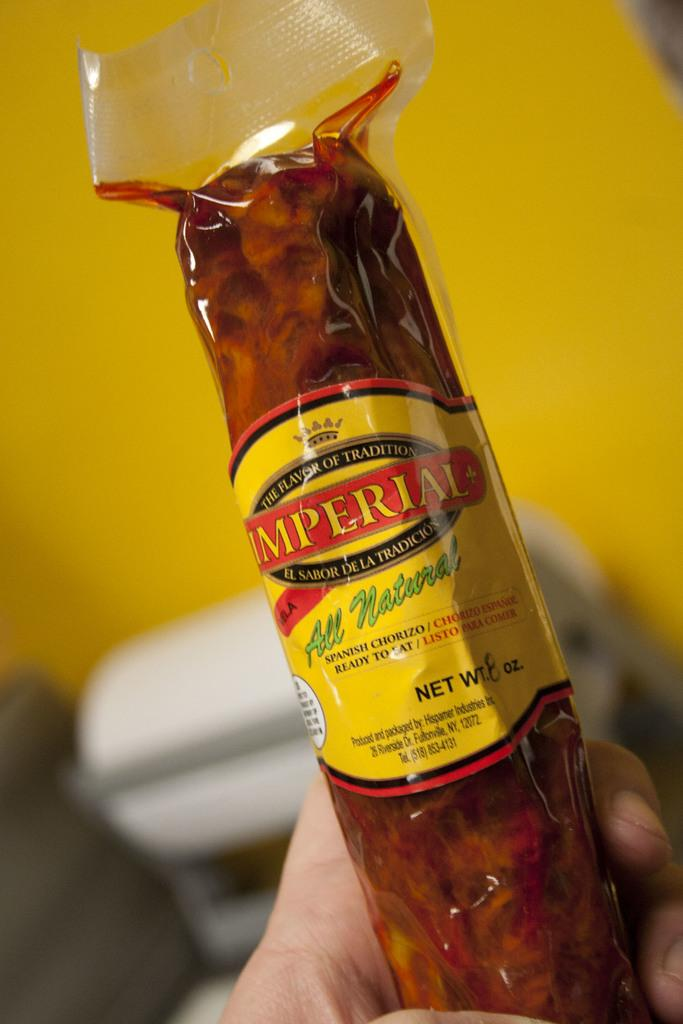<image>
Write a terse but informative summary of the picture. someone holding up a package of imperial chorizo 